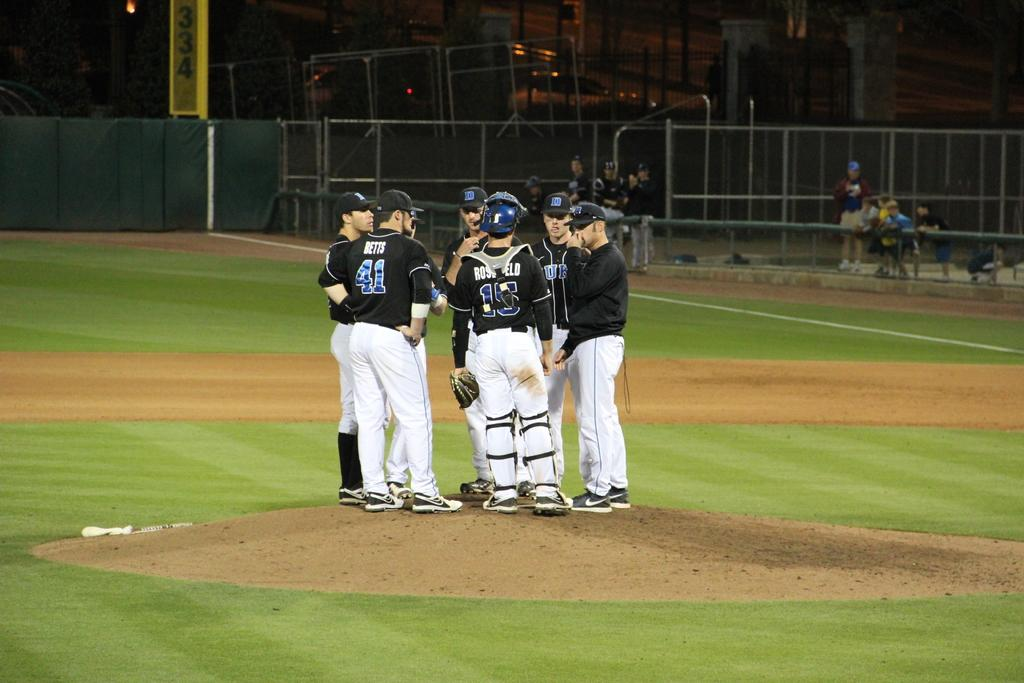<image>
Describe the image concisely. A group of baseball players are huddled on the pitcher mound and the catcher's uniform says Rosefeld. 